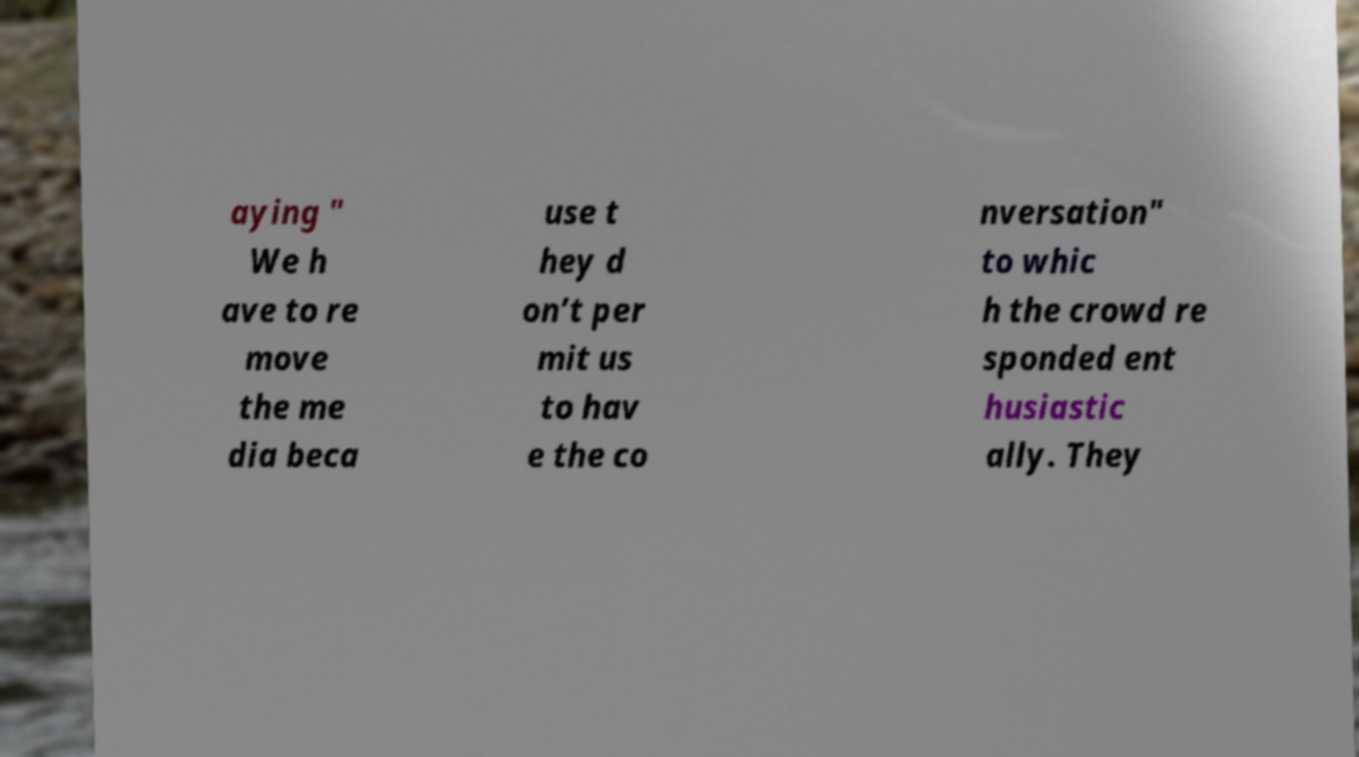Please identify and transcribe the text found in this image. aying " We h ave to re move the me dia beca use t hey d on’t per mit us to hav e the co nversation" to whic h the crowd re sponded ent husiastic ally. They 